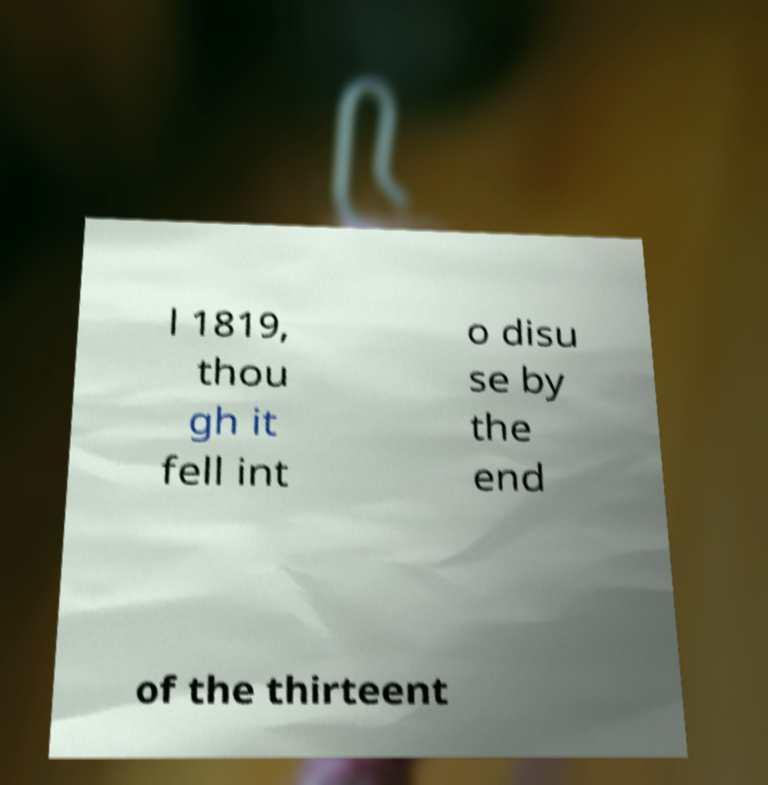Please identify and transcribe the text found in this image. l 1819, thou gh it fell int o disu se by the end of the thirteent 